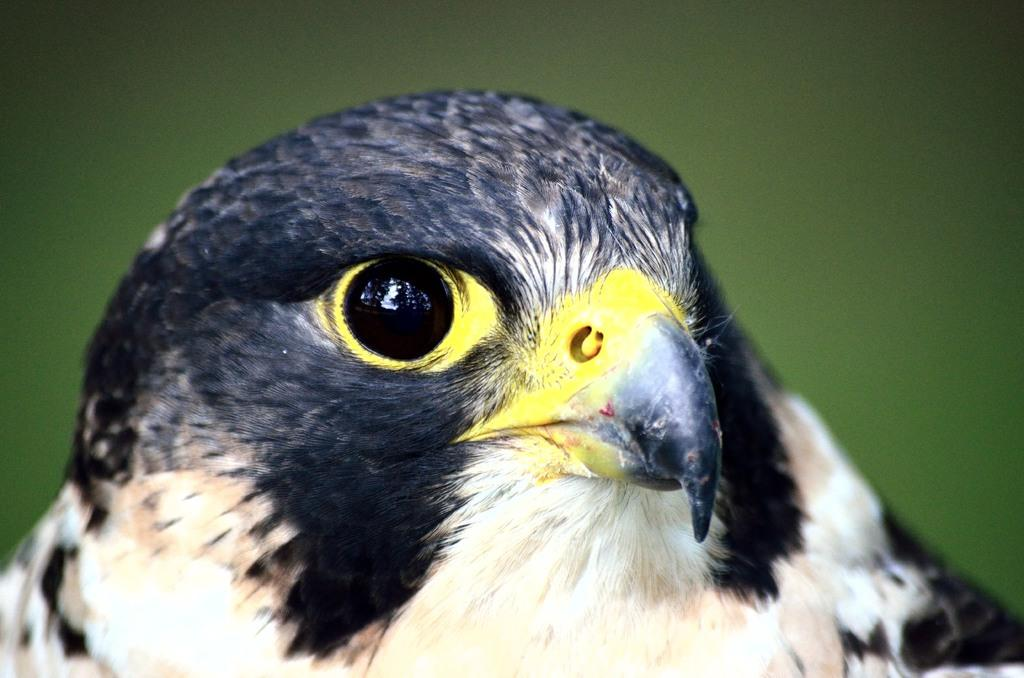What type of bird is in the picture? There is a Hawk bird in the picture. Can you describe the color pattern of the bird? The bird has a color pattern of white, black, yellow, and light brown. What type of toothpaste is the bird using in the picture? There is no toothpaste present in the image, and the bird is not using any toothpaste. 